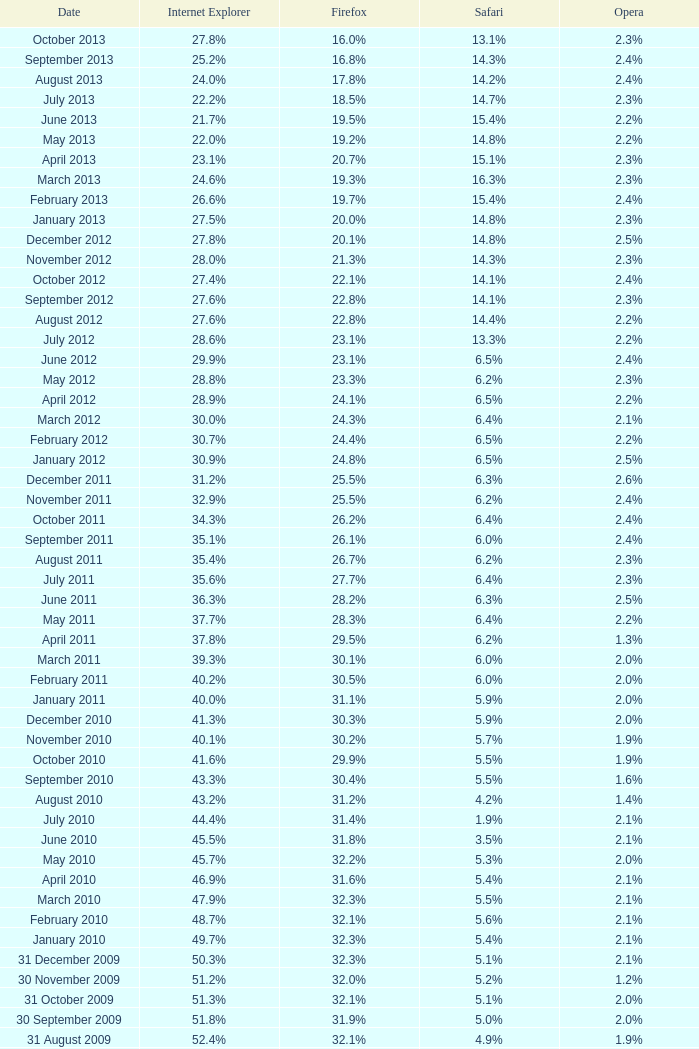What is the safari value with a 2.4% opera and 29.9% internet explorer? 6.5%. 